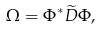Convert formula to latex. <formula><loc_0><loc_0><loc_500><loc_500>\Omega = \Phi ^ { * } \widetilde { D } \Phi ,</formula> 